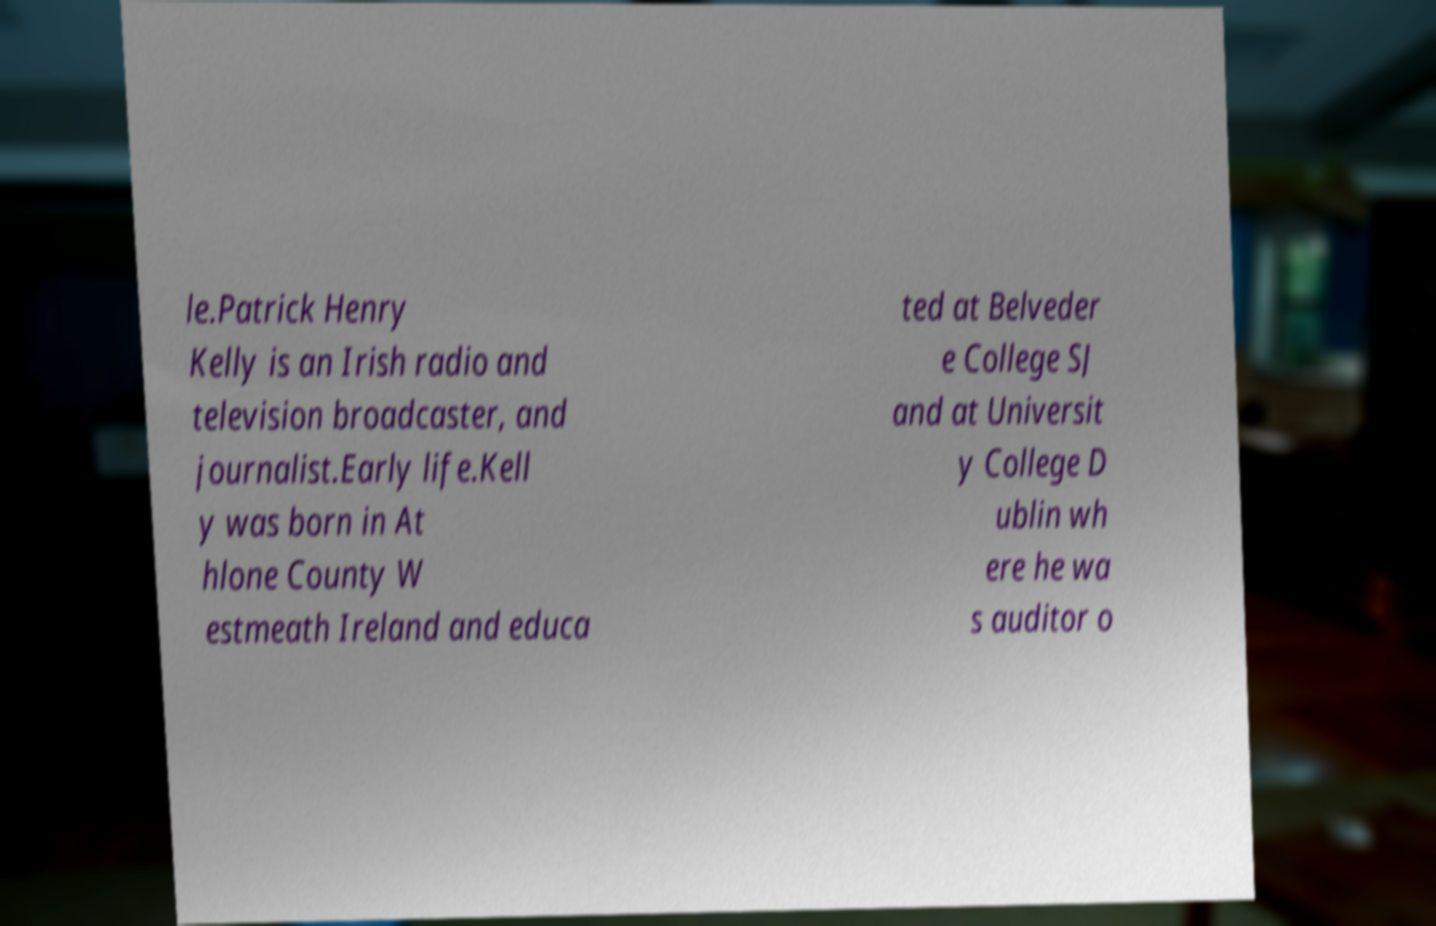Can you read and provide the text displayed in the image?This photo seems to have some interesting text. Can you extract and type it out for me? le.Patrick Henry Kelly is an Irish radio and television broadcaster, and journalist.Early life.Kell y was born in At hlone County W estmeath Ireland and educa ted at Belveder e College SJ and at Universit y College D ublin wh ere he wa s auditor o 